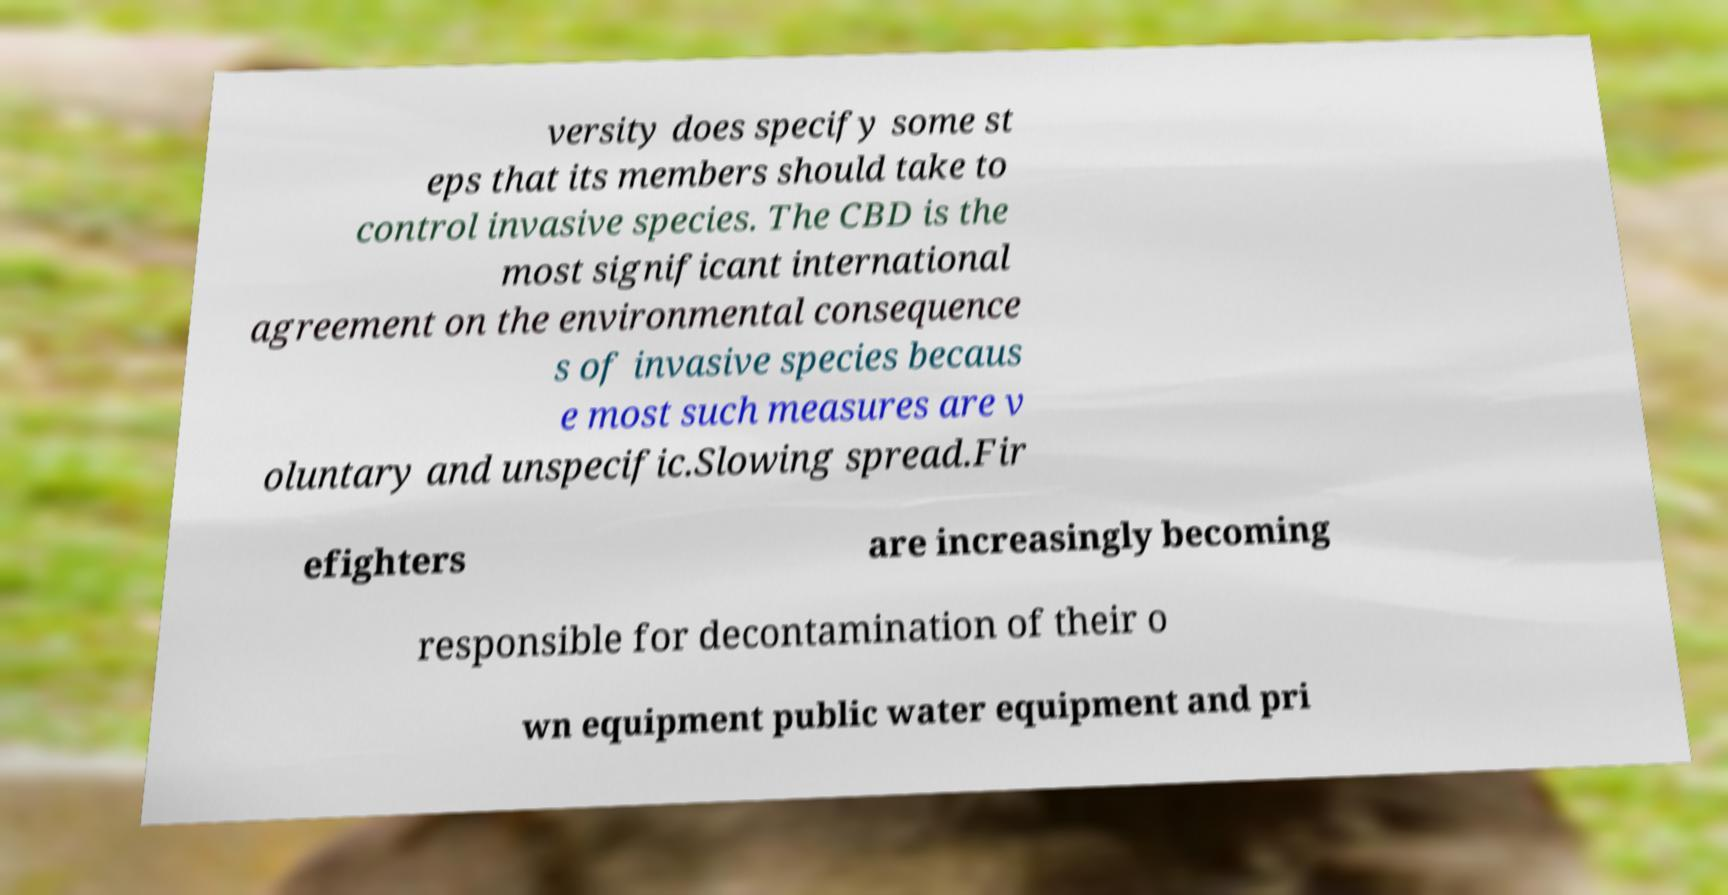Please read and relay the text visible in this image. What does it say? versity does specify some st eps that its members should take to control invasive species. The CBD is the most significant international agreement on the environmental consequence s of invasive species becaus e most such measures are v oluntary and unspecific.Slowing spread.Fir efighters are increasingly becoming responsible for decontamination of their o wn equipment public water equipment and pri 